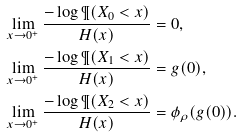<formula> <loc_0><loc_0><loc_500><loc_500>\lim _ { x \to 0 ^ { + } } \frac { - \log \P ( X _ { 0 } < x ) } { H ( x ) } & = 0 , \\ \lim _ { x \to 0 ^ { + } } \frac { - \log \P ( X _ { 1 } < x ) } { H ( x ) } & = g ( 0 ) , \\ \lim _ { x \to 0 ^ { + } } \frac { - \log \P ( X _ { 2 } < x ) } { H ( x ) } & = \phi _ { \rho } ( g ( 0 ) ) .</formula> 